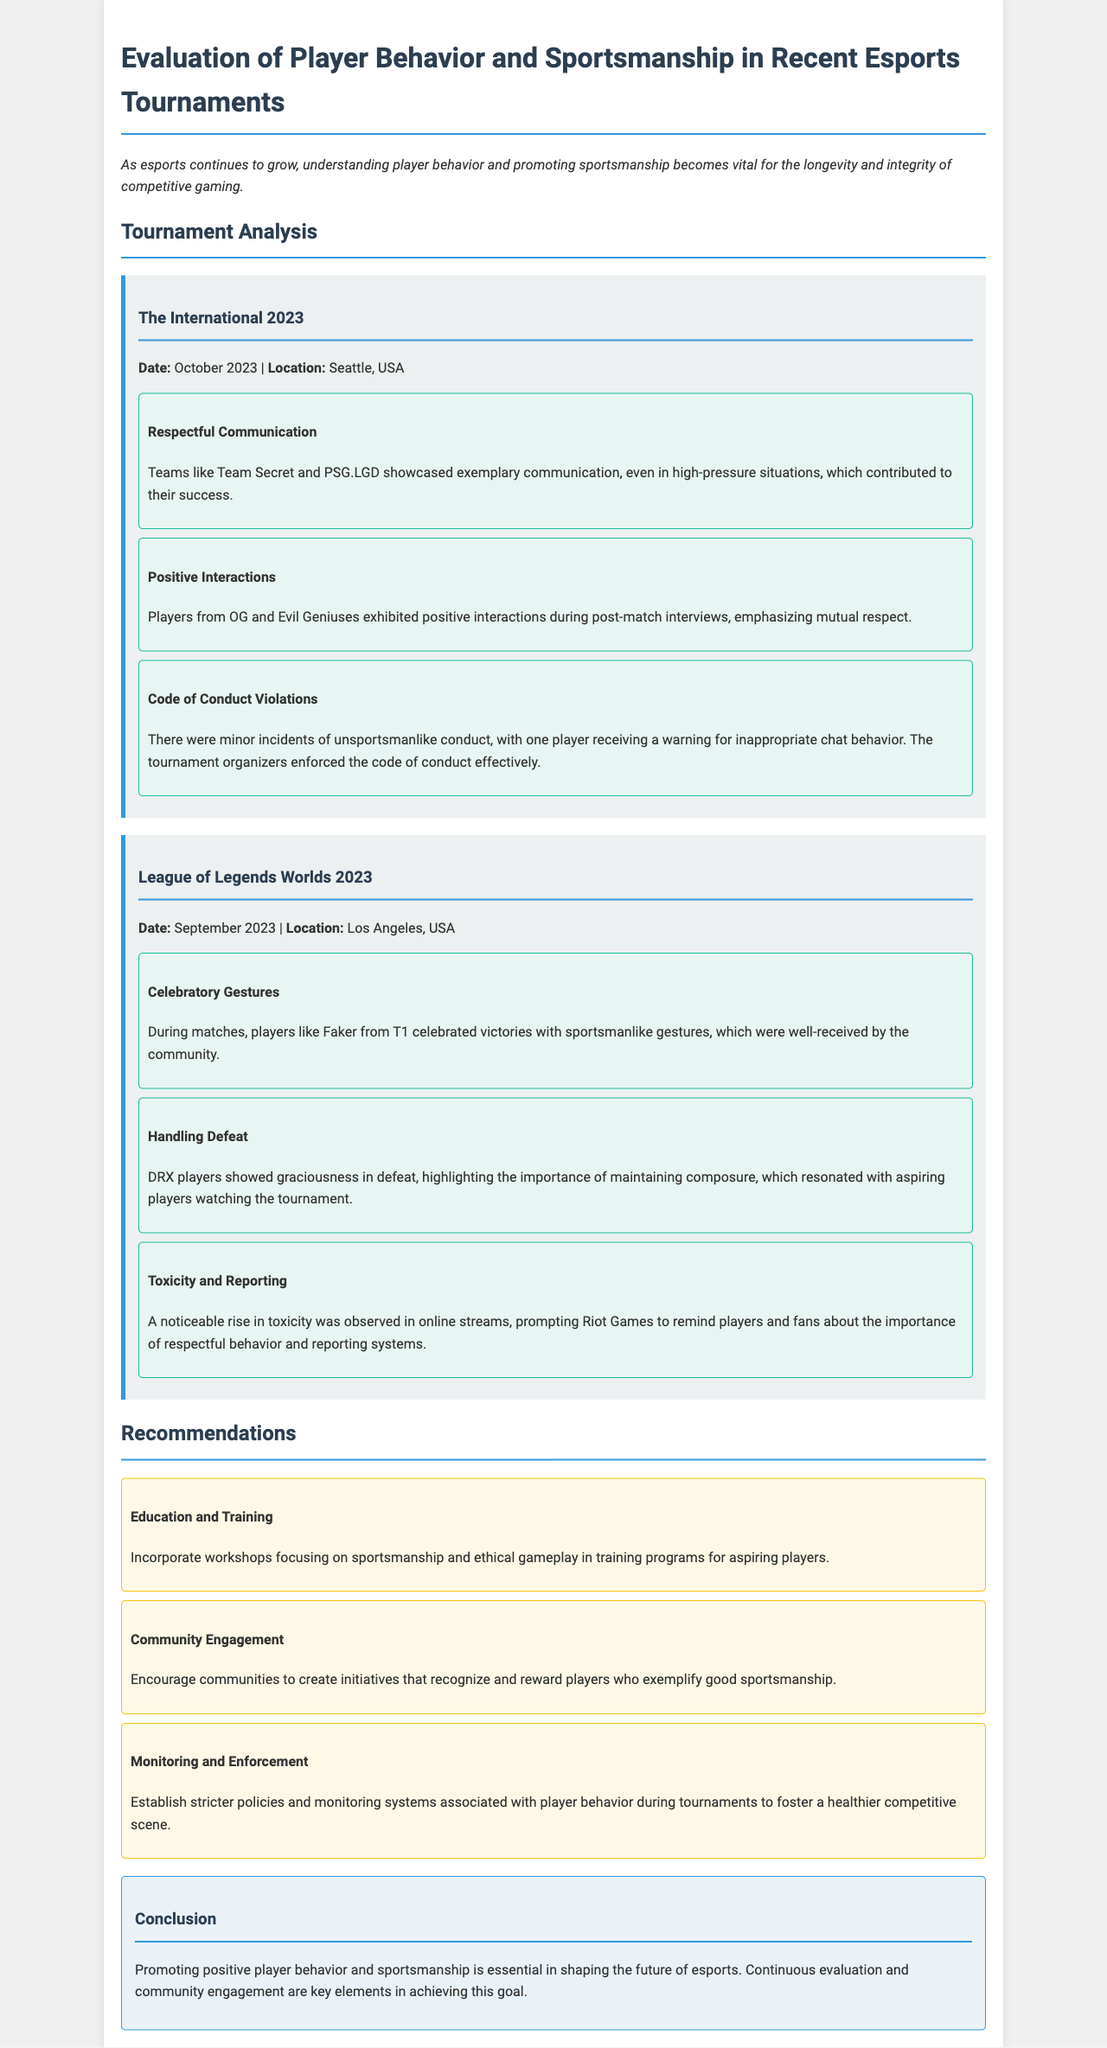what is the date of The International 2023? The date provided for The International 2023 is mentioned in the document under the tournament analysis section.
Answer: October 2023 who received a warning for inappropriate chat behavior? The document states that a player received a warning for inappropriate chat behavior, but does not specify the player's name.
Answer: One player which team celebrated victories with sportsmanlike gestures? The document mentions a specific player known for celebratory gestures during matches.
Answer: T1 what type of incidents were reported during The International 2023? The section about The International 2023 mentions specific types of conduct violations that occurred.
Answer: Code of Conduct Violations what is one recommendation for aspiring players regarding sportsmanship? The document includes various recommendations aimed at aspiring players, one of which focuses on training.
Answer: Incorporate workshops what should communities create to recognize sportsmanship? The recommendations section suggests community initiatives for rewarding players.
Answer: Initiatives how did DRX players handle defeat? The document contains a description of how a particular team approached their losses during the tournament.
Answer: Graciousness in defeat what is the location of League of Legends Worlds 2023? The document specifies the location of the League of Legends Worlds 2023 event within the tournament analysis.
Answer: Los Angeles, USA what is an observed issue during online streams? The document points out a specific problem regarding behavior observed during online tournaments.
Answer: Toxicity 